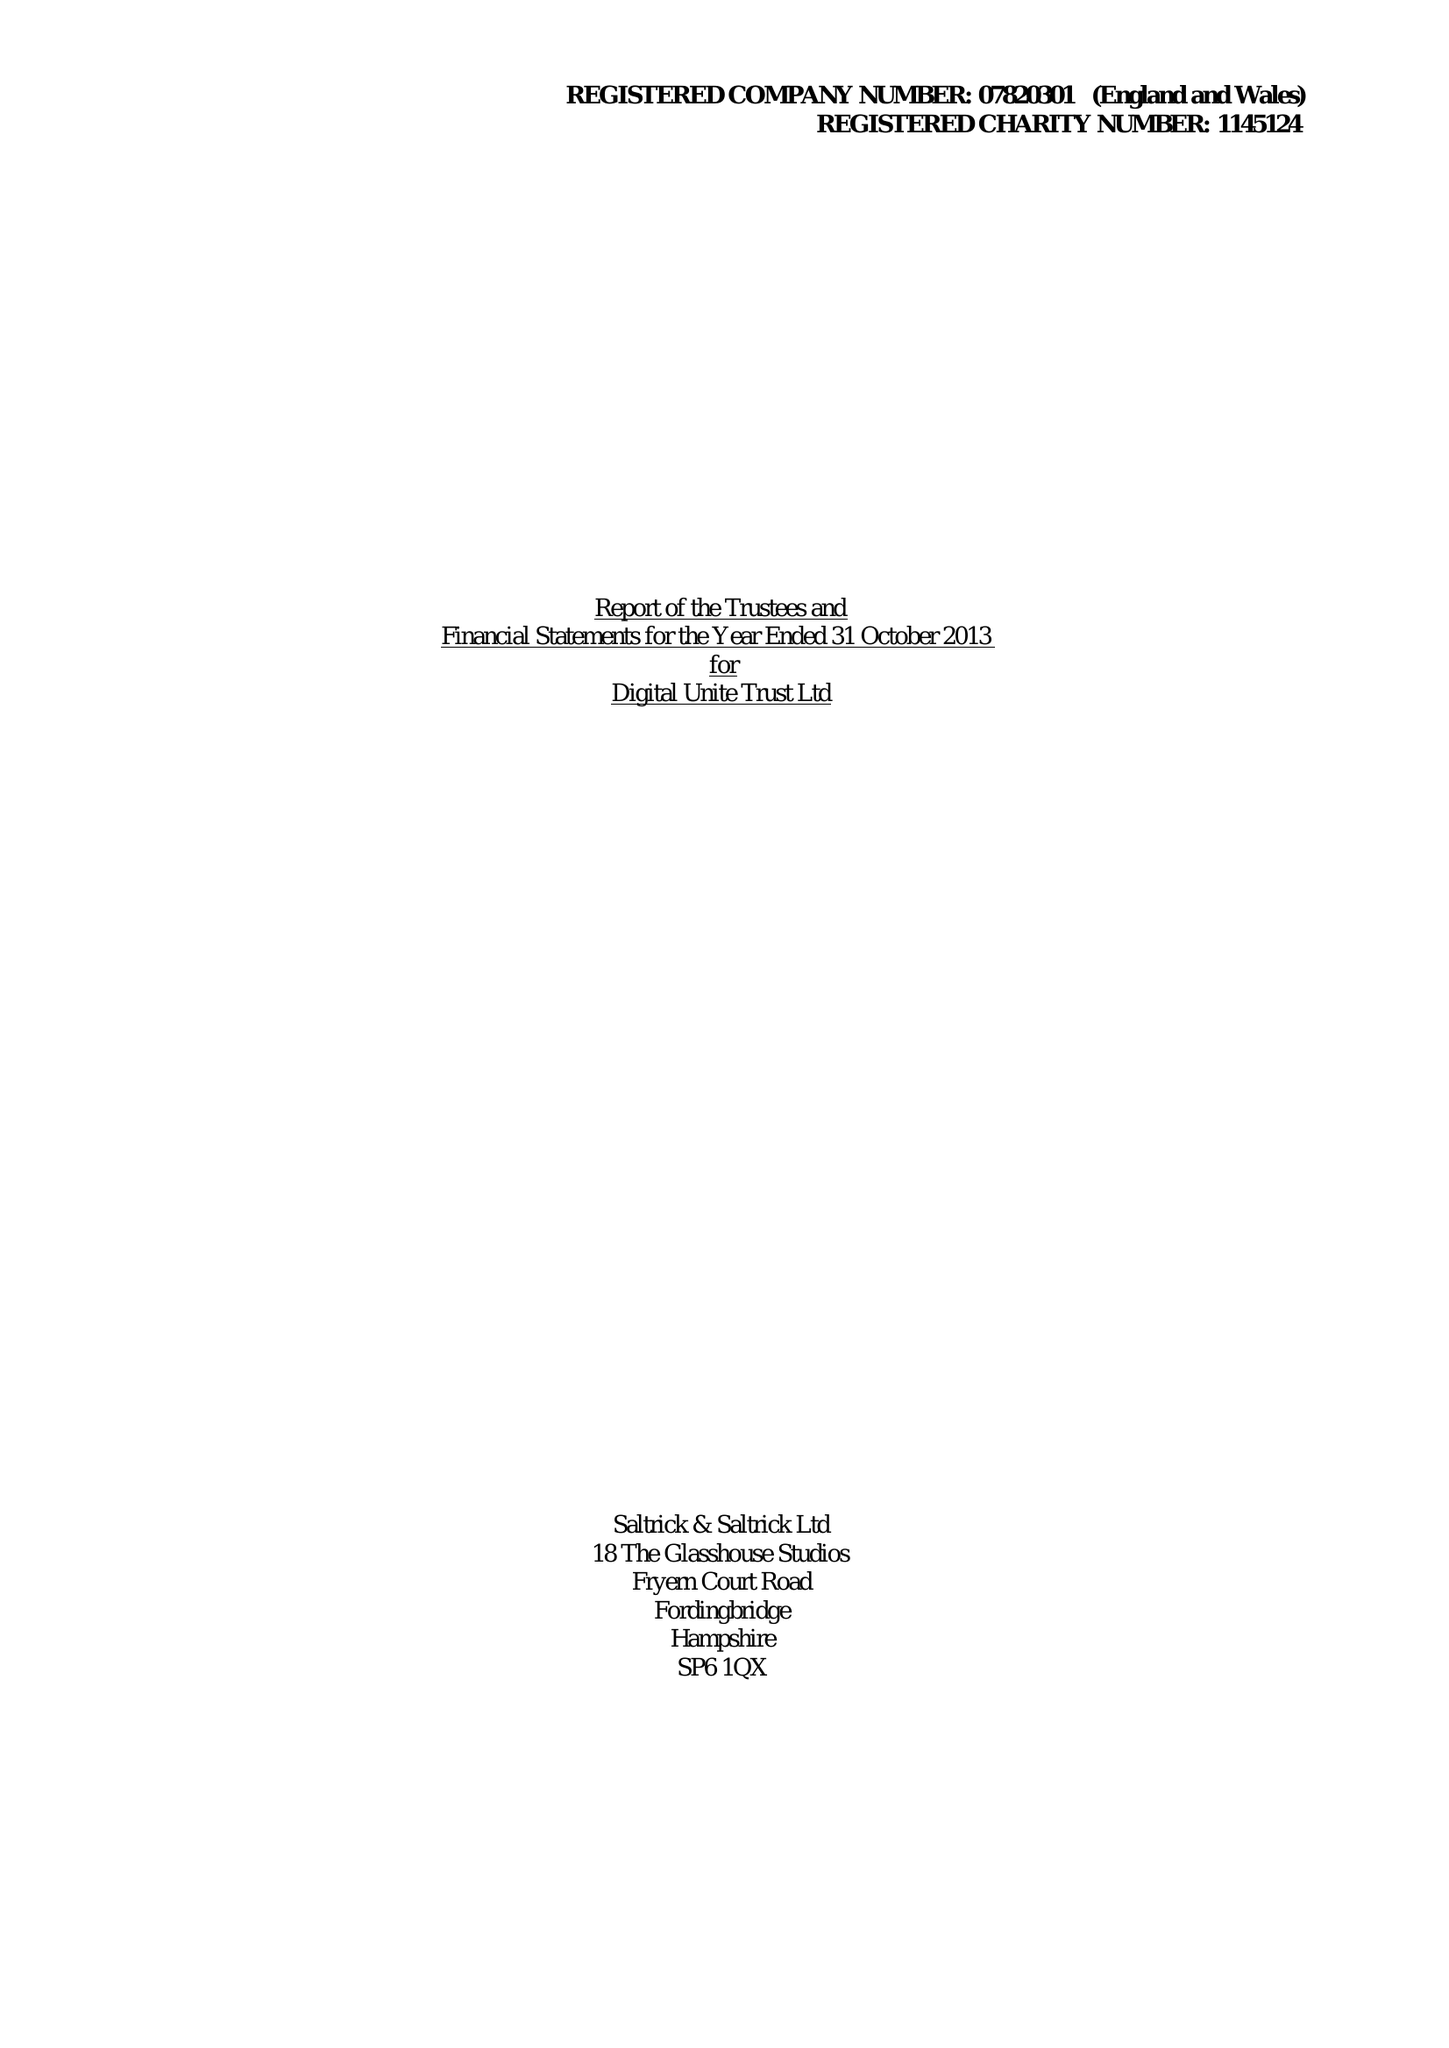What is the value for the address__street_line?
Answer the question using a single word or phrase. None 